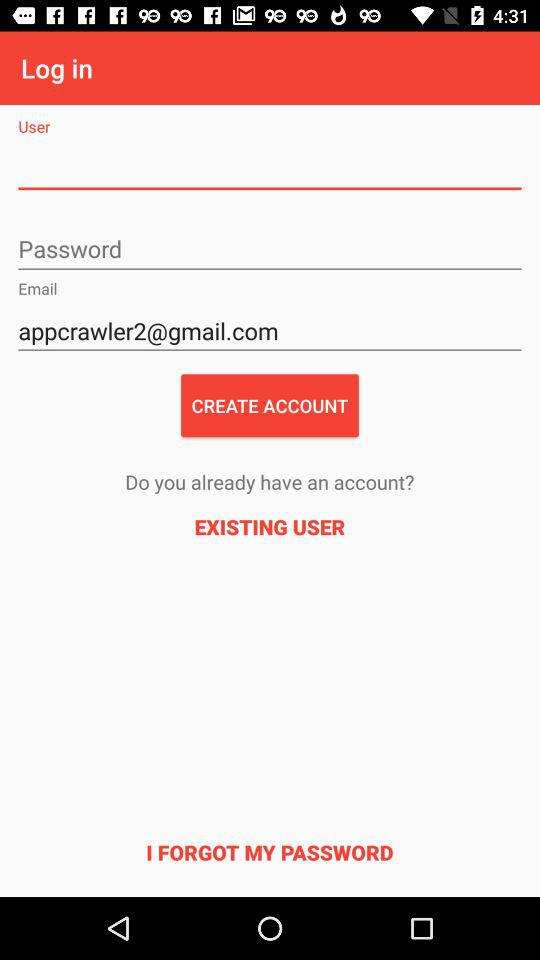What is the user's name?
When the provided information is insufficient, respond with <no answer>. <no answer> 